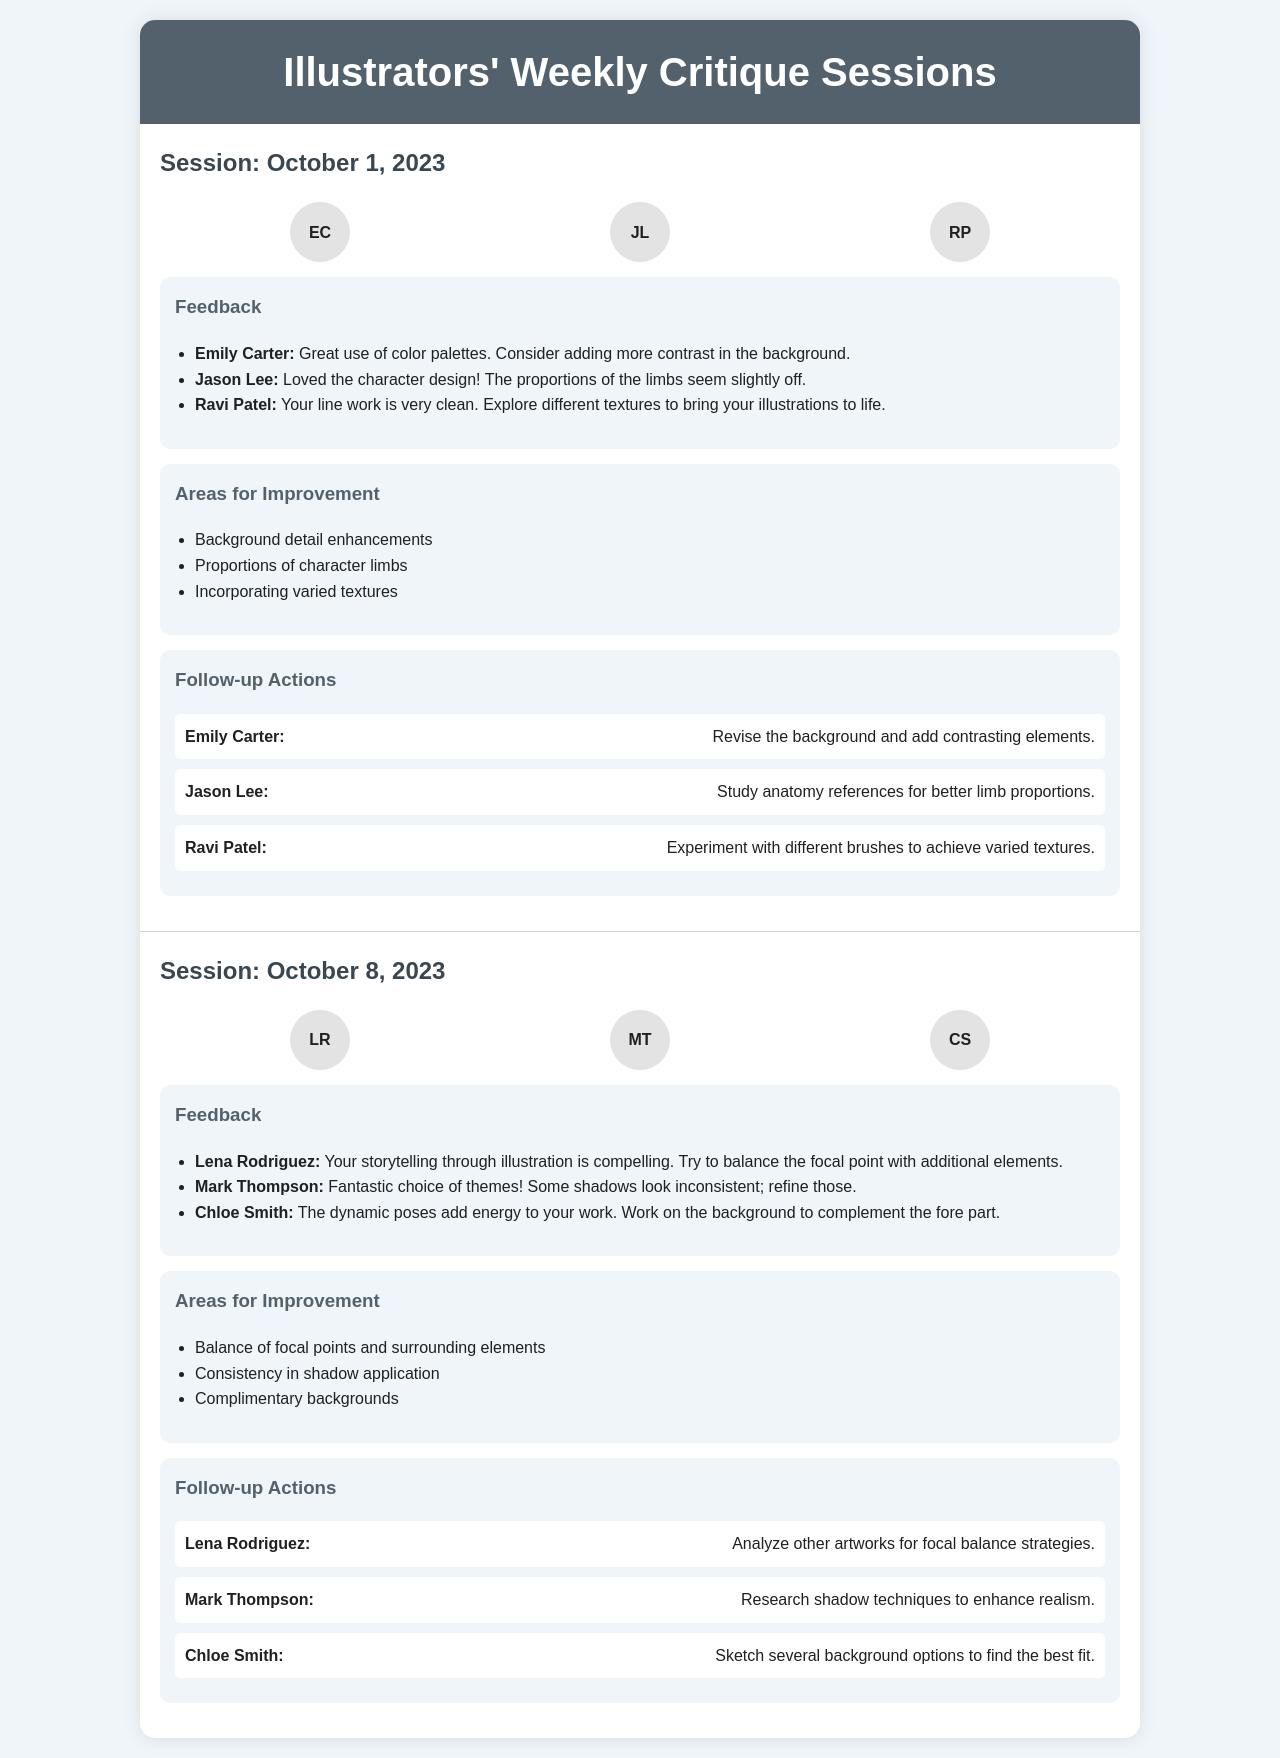What is the date of the first critique session? The date of the first critique session can be found in the heading of the session section, which is October 1, 2023.
Answer: October 1, 2023 Who provided feedback on the character design? The feedback on the character design is specifically attributed to Jason Lee in the feedback section of the first session.
Answer: Jason Lee What are the areas for improvement listed in the second session? The areas for improvement from the second session are detailed in the respective section, listing three key points of focus.
Answer: Balance of focal points and surrounding elements, Consistency in shadow application, Complimentary backgrounds How many participants attended the first session? The number of participants can be counted from the participant section of the first session, which lists three individuals.
Answer: 3 What was one of Ravi Patel's suggestions for improvement? Ravi Patel suggested exploring different textures, which is mentioned in the areas for improvement of the first session.
Answer: Incorporating varied textures What is one follow-up action assigned to Mark Thompson? The follow-up action assigned to Mark Thompson involves researching shadow techniques, as noted in the follow-up actions section of the second session.
Answer: Research shadow techniques to enhance realism Which participant emphasized storytelling through illustration? The participant emphasizing storytelling through illustration is identified in the feedback from the second session, which highlights this aspect.
Answer: Lena Rodriguez What color palette feedback did Emily Carter give? Emily Carter provided feedback regarding the use of color palettes, specifically mentioning the addition of contrast.
Answer: Consider adding more contrast in the background 